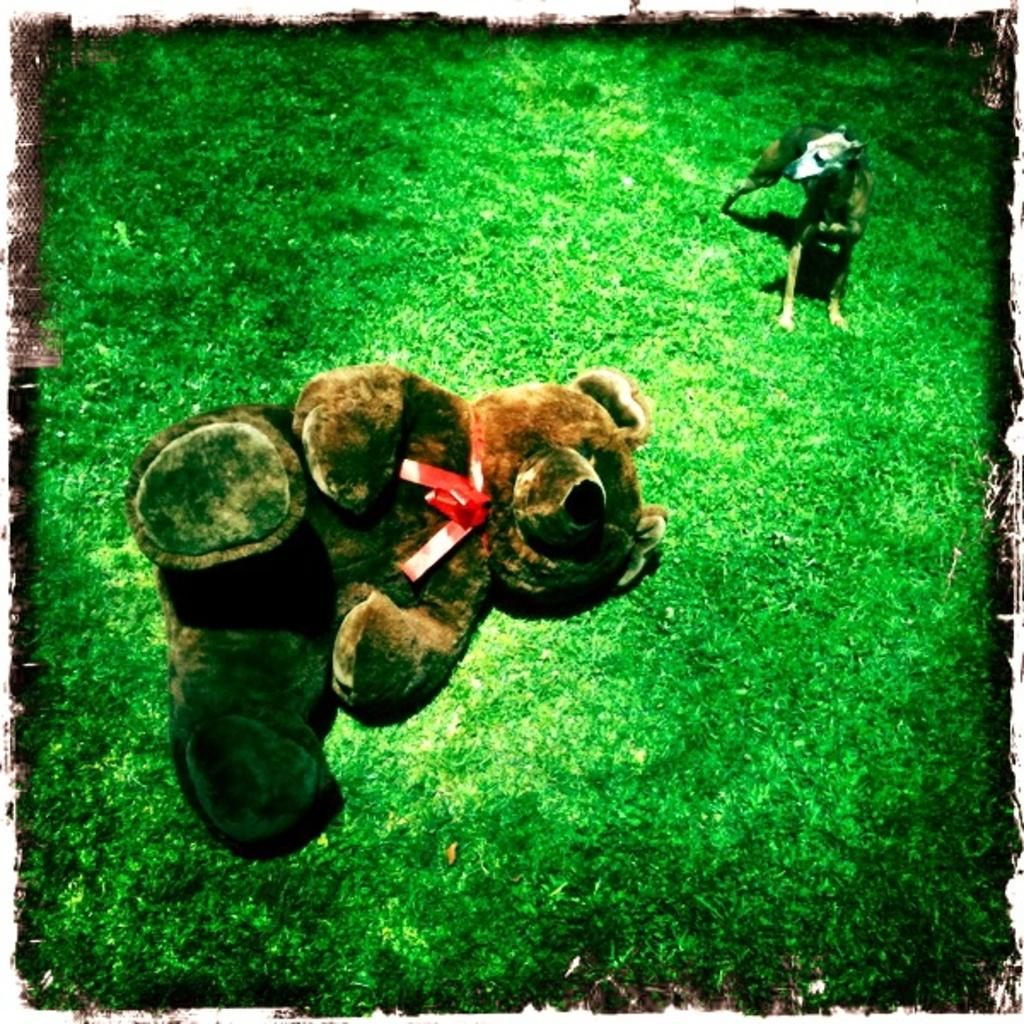What type of doll is on the grass in the image? There is a brown color doll on the grass in the image. Where is the doll located in relation to the ground? The doll is on the ground. What animal can be seen on the right side of the image? There is a dog on the right side of the image. Where is the dog standing in the image? The dog is standing on the grass. Can you describe the dog's position in the image? The dog is on the ground, standing on the grass. What type of beast is present at the winter meeting in the image? There is no beast or winter meeting present in the image. 